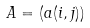<formula> <loc_0><loc_0><loc_500><loc_500>A = ( a ( i , j ) )</formula> 